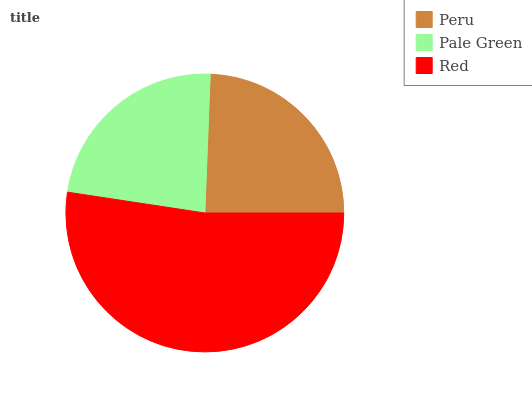Is Pale Green the minimum?
Answer yes or no. Yes. Is Red the maximum?
Answer yes or no. Yes. Is Red the minimum?
Answer yes or no. No. Is Pale Green the maximum?
Answer yes or no. No. Is Red greater than Pale Green?
Answer yes or no. Yes. Is Pale Green less than Red?
Answer yes or no. Yes. Is Pale Green greater than Red?
Answer yes or no. No. Is Red less than Pale Green?
Answer yes or no. No. Is Peru the high median?
Answer yes or no. Yes. Is Peru the low median?
Answer yes or no. Yes. Is Pale Green the high median?
Answer yes or no. No. Is Pale Green the low median?
Answer yes or no. No. 